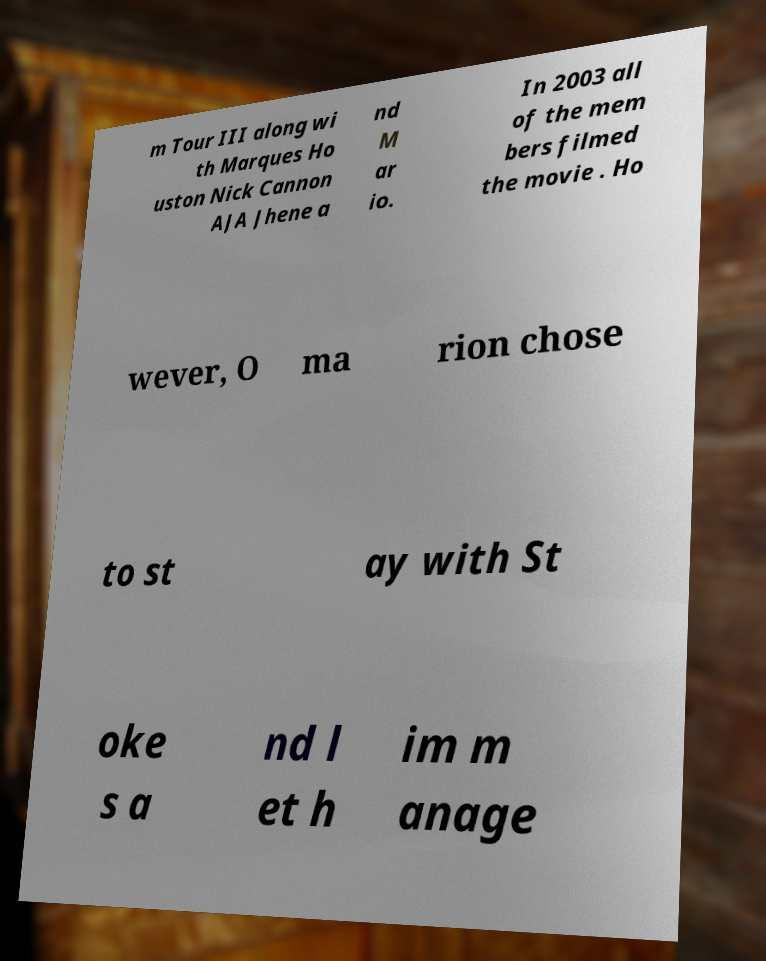There's text embedded in this image that I need extracted. Can you transcribe it verbatim? m Tour III along wi th Marques Ho uston Nick Cannon AJA Jhene a nd M ar io. In 2003 all of the mem bers filmed the movie . Ho wever, O ma rion chose to st ay with St oke s a nd l et h im m anage 